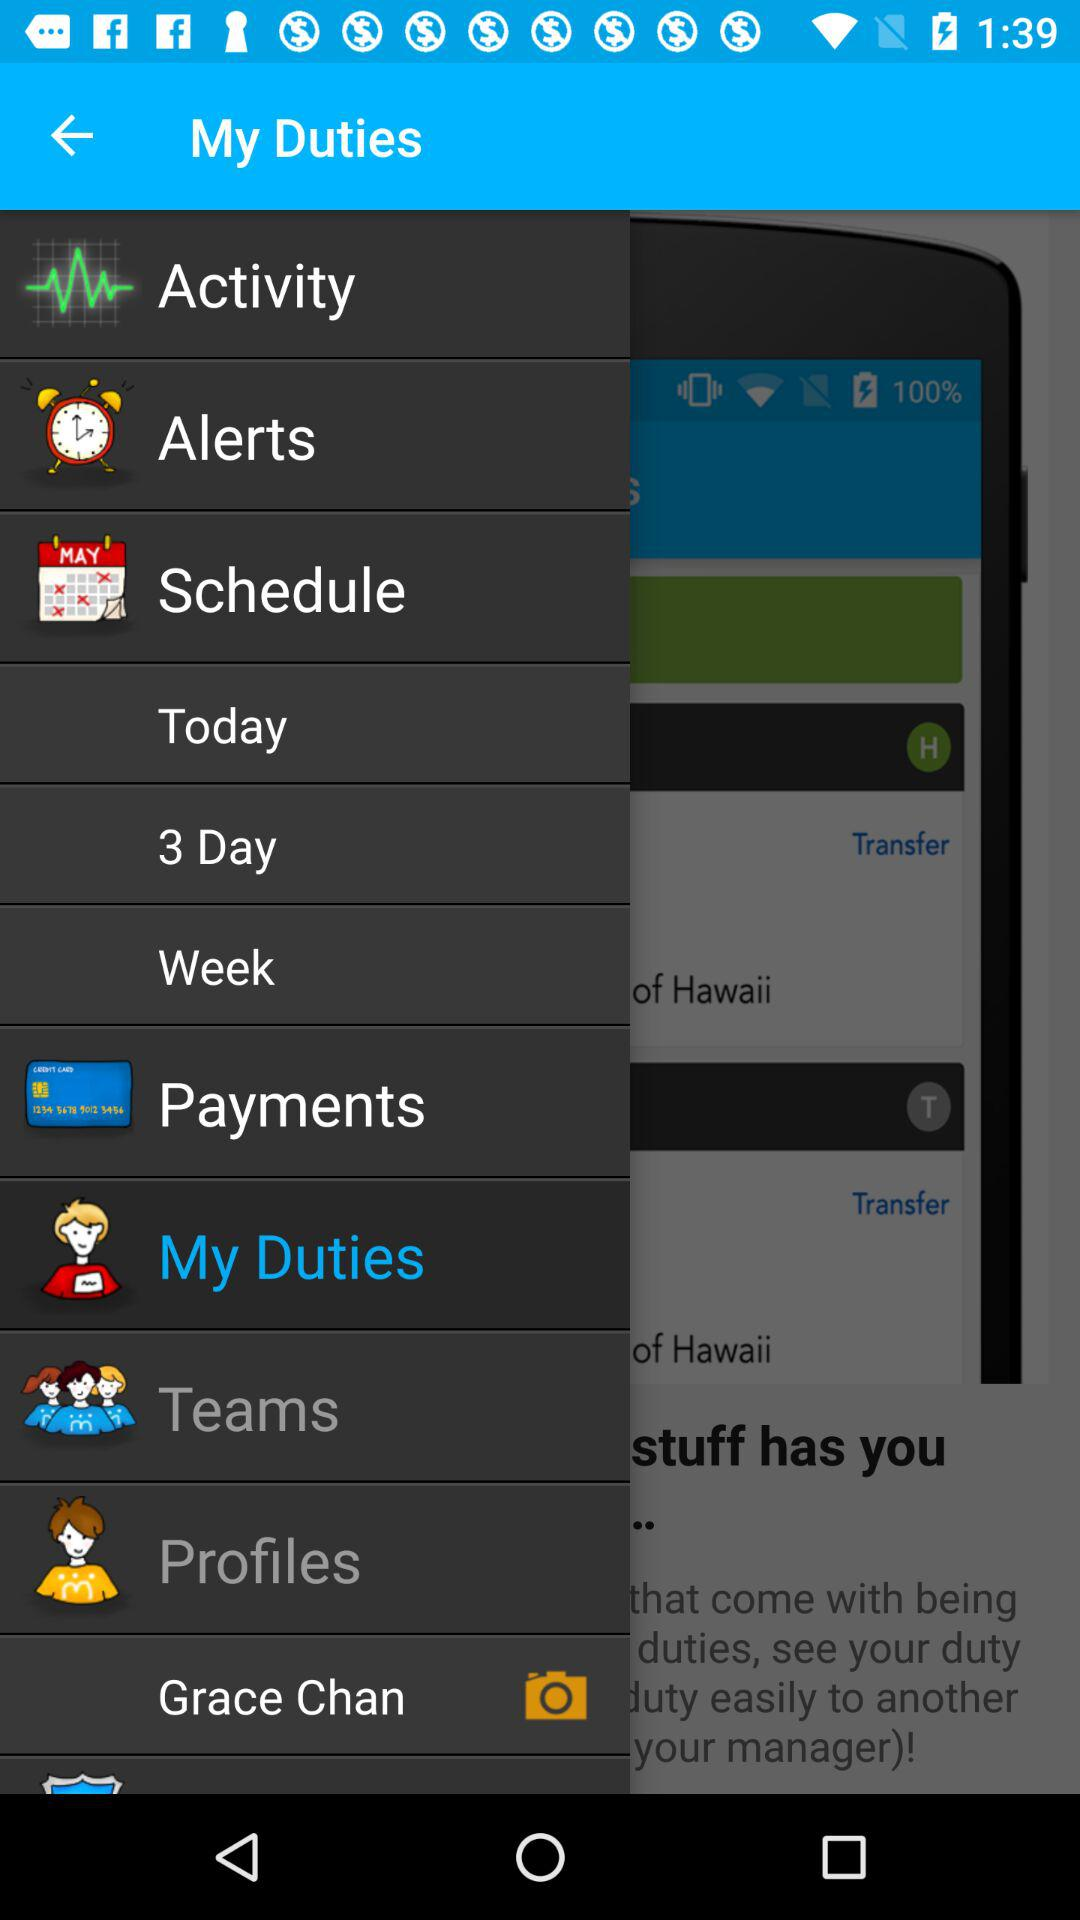When did Grace Chan upload a photo?
When the provided information is insufficient, respond with <no answer>. <no answer> 